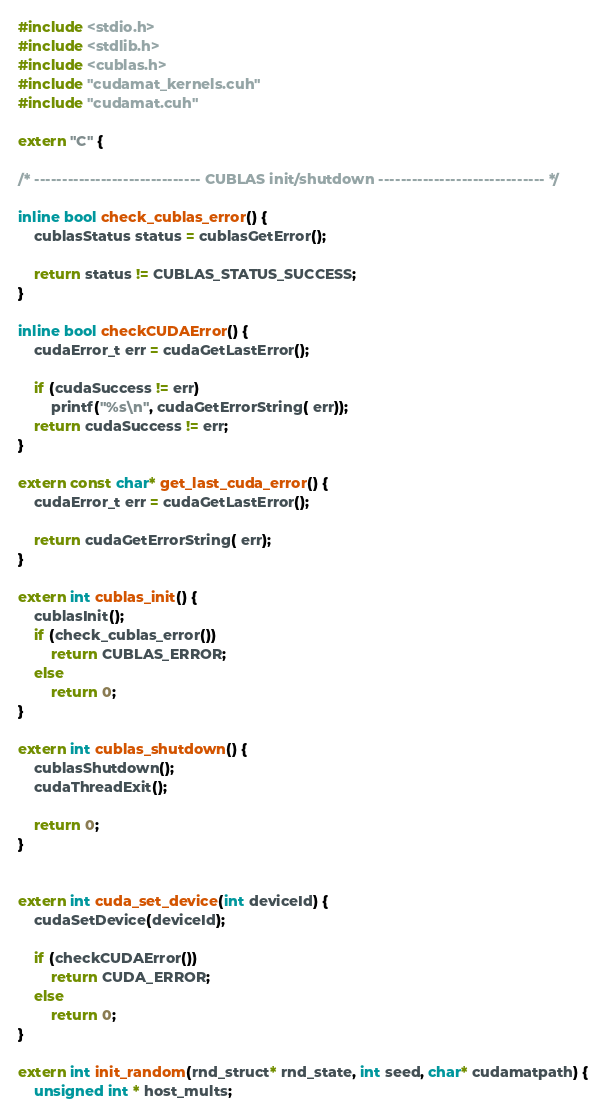Convert code to text. <code><loc_0><loc_0><loc_500><loc_500><_Cuda_>#include <stdio.h>
#include <stdlib.h>
#include <cublas.h>
#include "cudamat_kernels.cuh"
#include "cudamat.cuh"

extern "C" {

/* ------------------------------ CUBLAS init/shutdown ------------------------------ */

inline bool check_cublas_error() {
    cublasStatus status = cublasGetError();

    return status != CUBLAS_STATUS_SUCCESS;
}

inline bool checkCUDAError() {
    cudaError_t err = cudaGetLastError();

    if (cudaSuccess != err)
        printf("%s\n", cudaGetErrorString( err));
    return cudaSuccess != err;
}

extern const char* get_last_cuda_error() {
    cudaError_t err = cudaGetLastError();

    return cudaGetErrorString( err);
}

extern int cublas_init() {
    cublasInit();
    if (check_cublas_error())
        return CUBLAS_ERROR;
    else
        return 0;
}

extern int cublas_shutdown() {
    cublasShutdown();
    cudaThreadExit();

    return 0;
}


extern int cuda_set_device(int deviceId) {
    cudaSetDevice(deviceId);
    
    if (checkCUDAError())
        return CUDA_ERROR;
    else
        return 0;
}

extern int init_random(rnd_struct* rnd_state, int seed, char* cudamatpath) {
    unsigned int * host_mults;</code> 